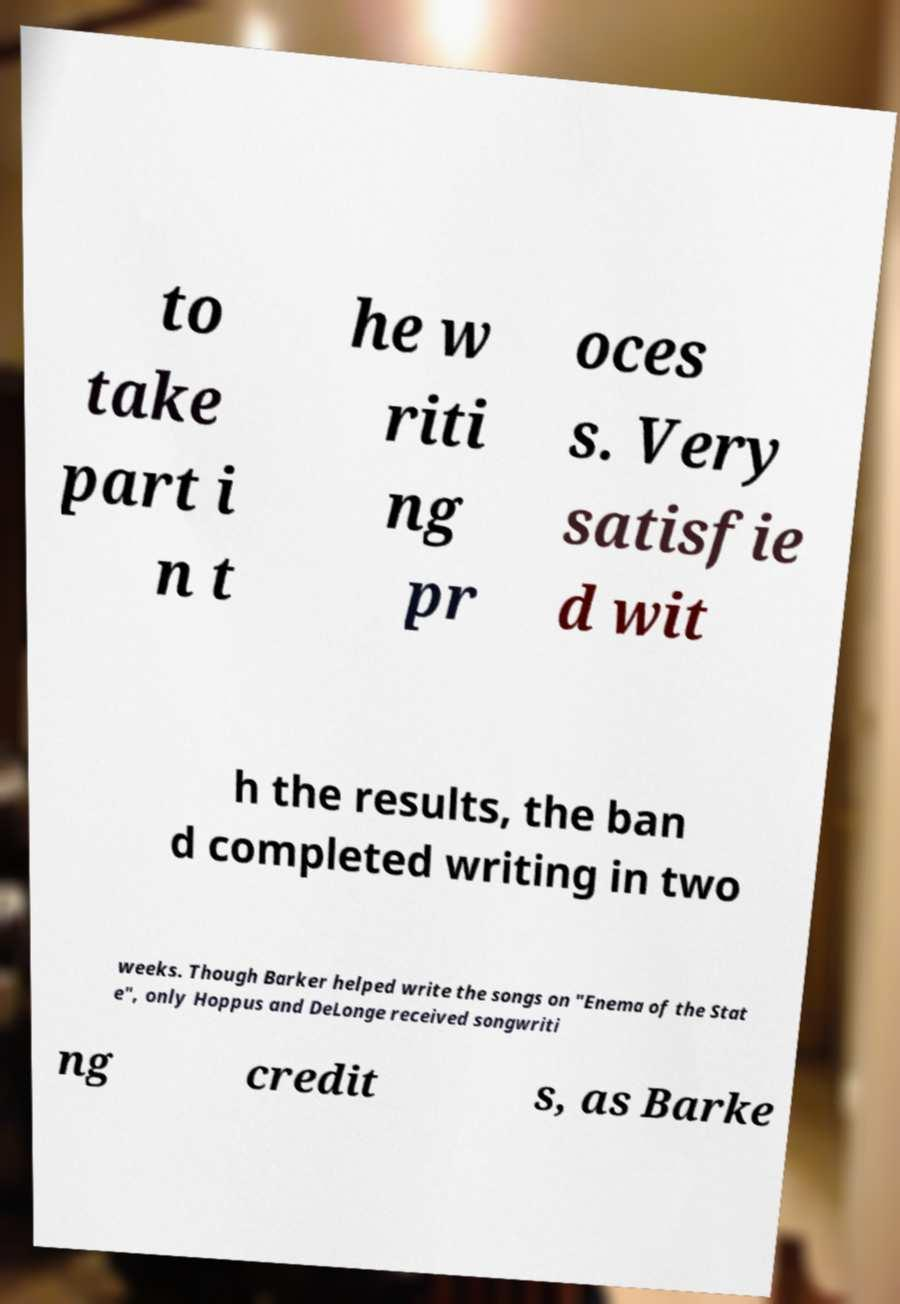Can you accurately transcribe the text from the provided image for me? to take part i n t he w riti ng pr oces s. Very satisfie d wit h the results, the ban d completed writing in two weeks. Though Barker helped write the songs on "Enema of the Stat e", only Hoppus and DeLonge received songwriti ng credit s, as Barke 